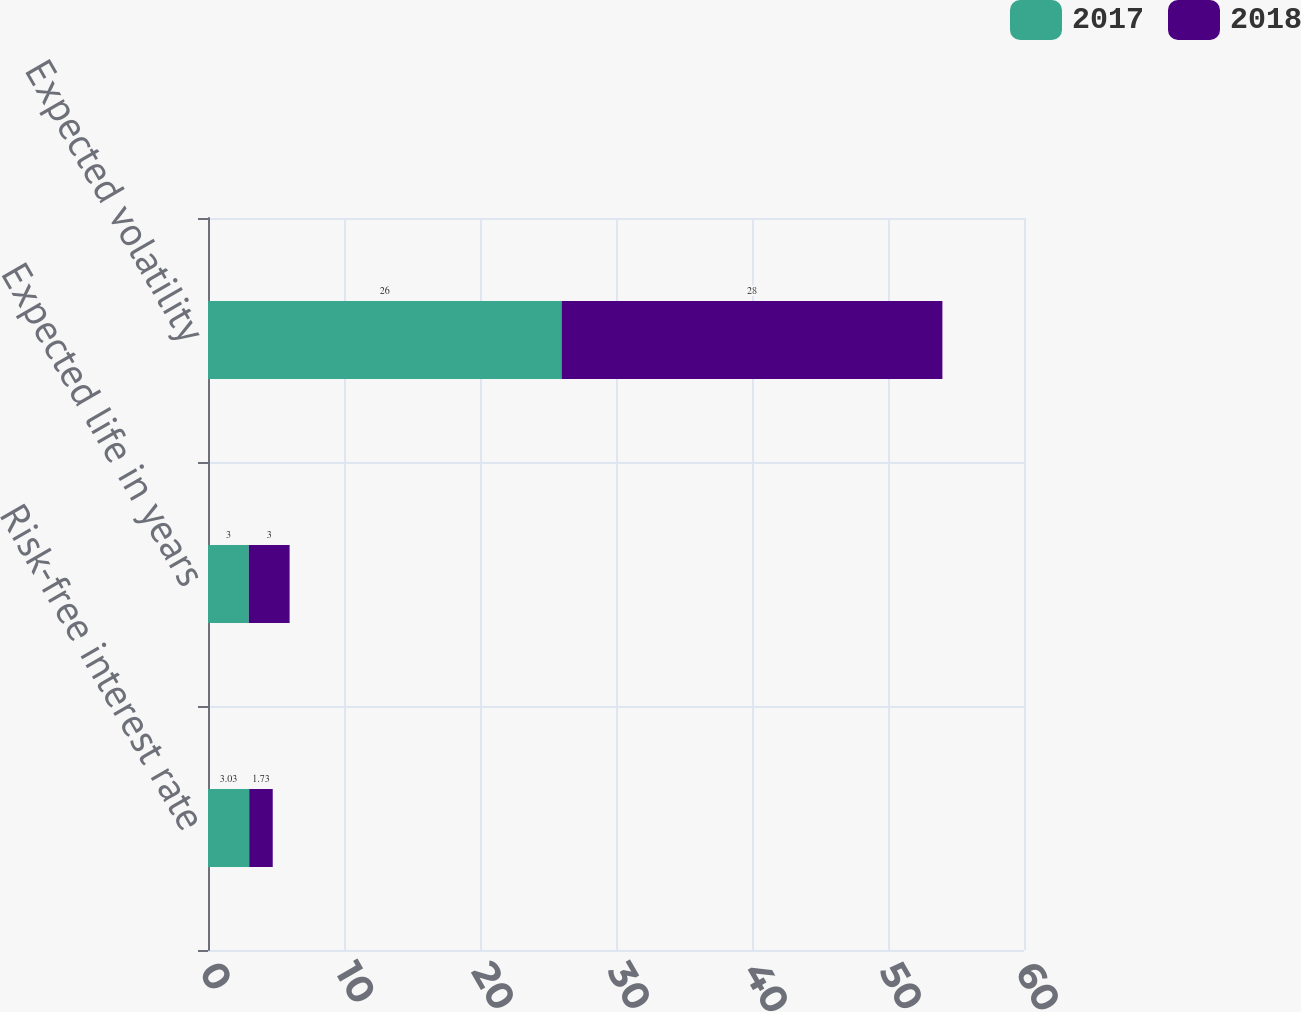<chart> <loc_0><loc_0><loc_500><loc_500><stacked_bar_chart><ecel><fcel>Risk-free interest rate<fcel>Expected life in years<fcel>Expected volatility<nl><fcel>2017<fcel>3.03<fcel>3<fcel>26<nl><fcel>2018<fcel>1.73<fcel>3<fcel>28<nl></chart> 